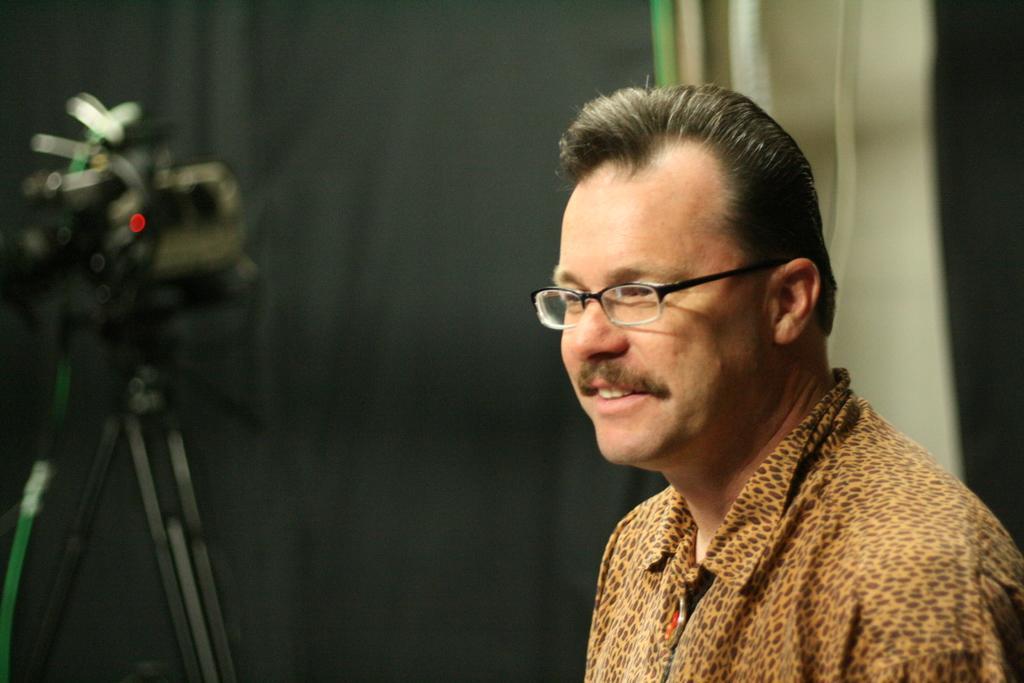Can you describe this image briefly? In the image,there is a man,he is wearing animal printed shirt and spectacles and the background of the man is blur. 